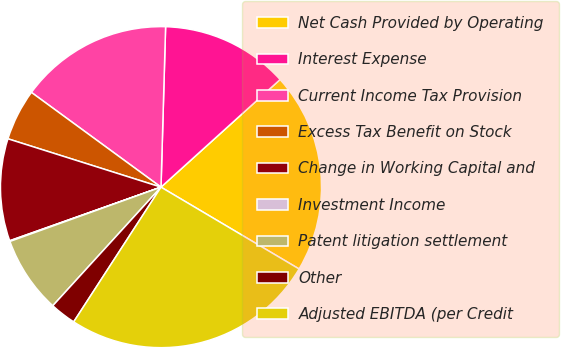<chart> <loc_0><loc_0><loc_500><loc_500><pie_chart><fcel>Net Cash Provided by Operating<fcel>Interest Expense<fcel>Current Income Tax Provision<fcel>Excess Tax Benefit on Stock<fcel>Change in Working Capital and<fcel>Investment Income<fcel>Patent litigation settlement<fcel>Other<fcel>Adjusted EBITDA (per Credit<nl><fcel>20.21%<fcel>12.85%<fcel>15.41%<fcel>5.18%<fcel>10.29%<fcel>0.07%<fcel>7.74%<fcel>2.62%<fcel>25.64%<nl></chart> 